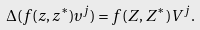Convert formula to latex. <formula><loc_0><loc_0><loc_500><loc_500>\Delta ( f ( z , z ^ { * } ) \upsilon ^ { j } ) = f ( Z , Z ^ { * } ) V ^ { j } .</formula> 